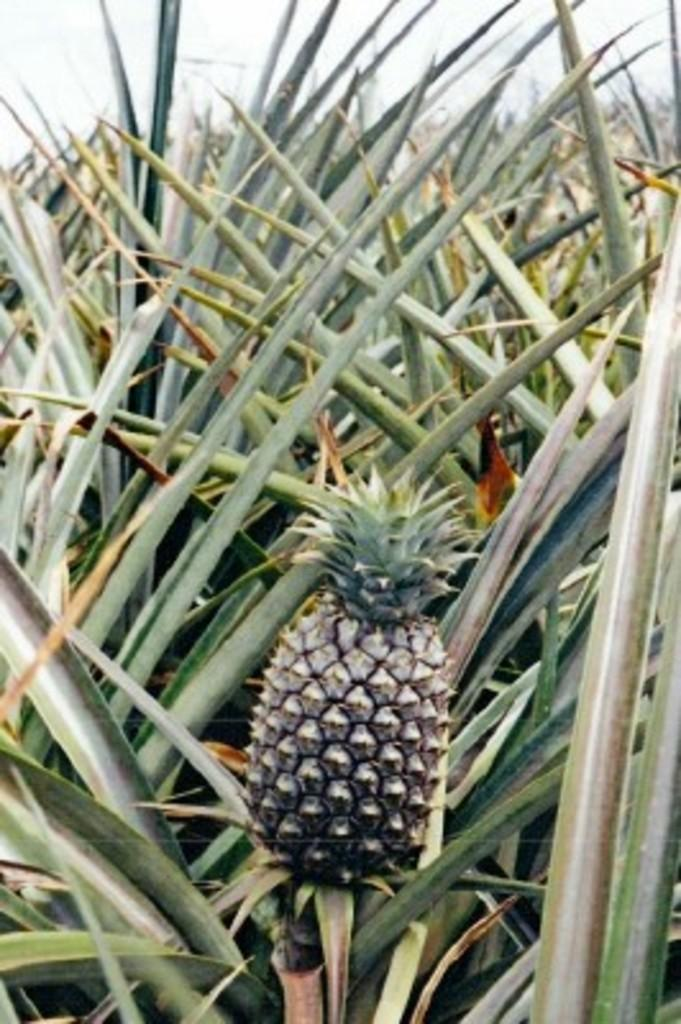What type of vegetation is present in the image? There is grass in the image. What object can be seen on the grass? There is a pineapple visible on the grass. What type of prose can be heard in the background of the image? There is no audible prose present in the image, as it is a still image of grass and a pineapple. 